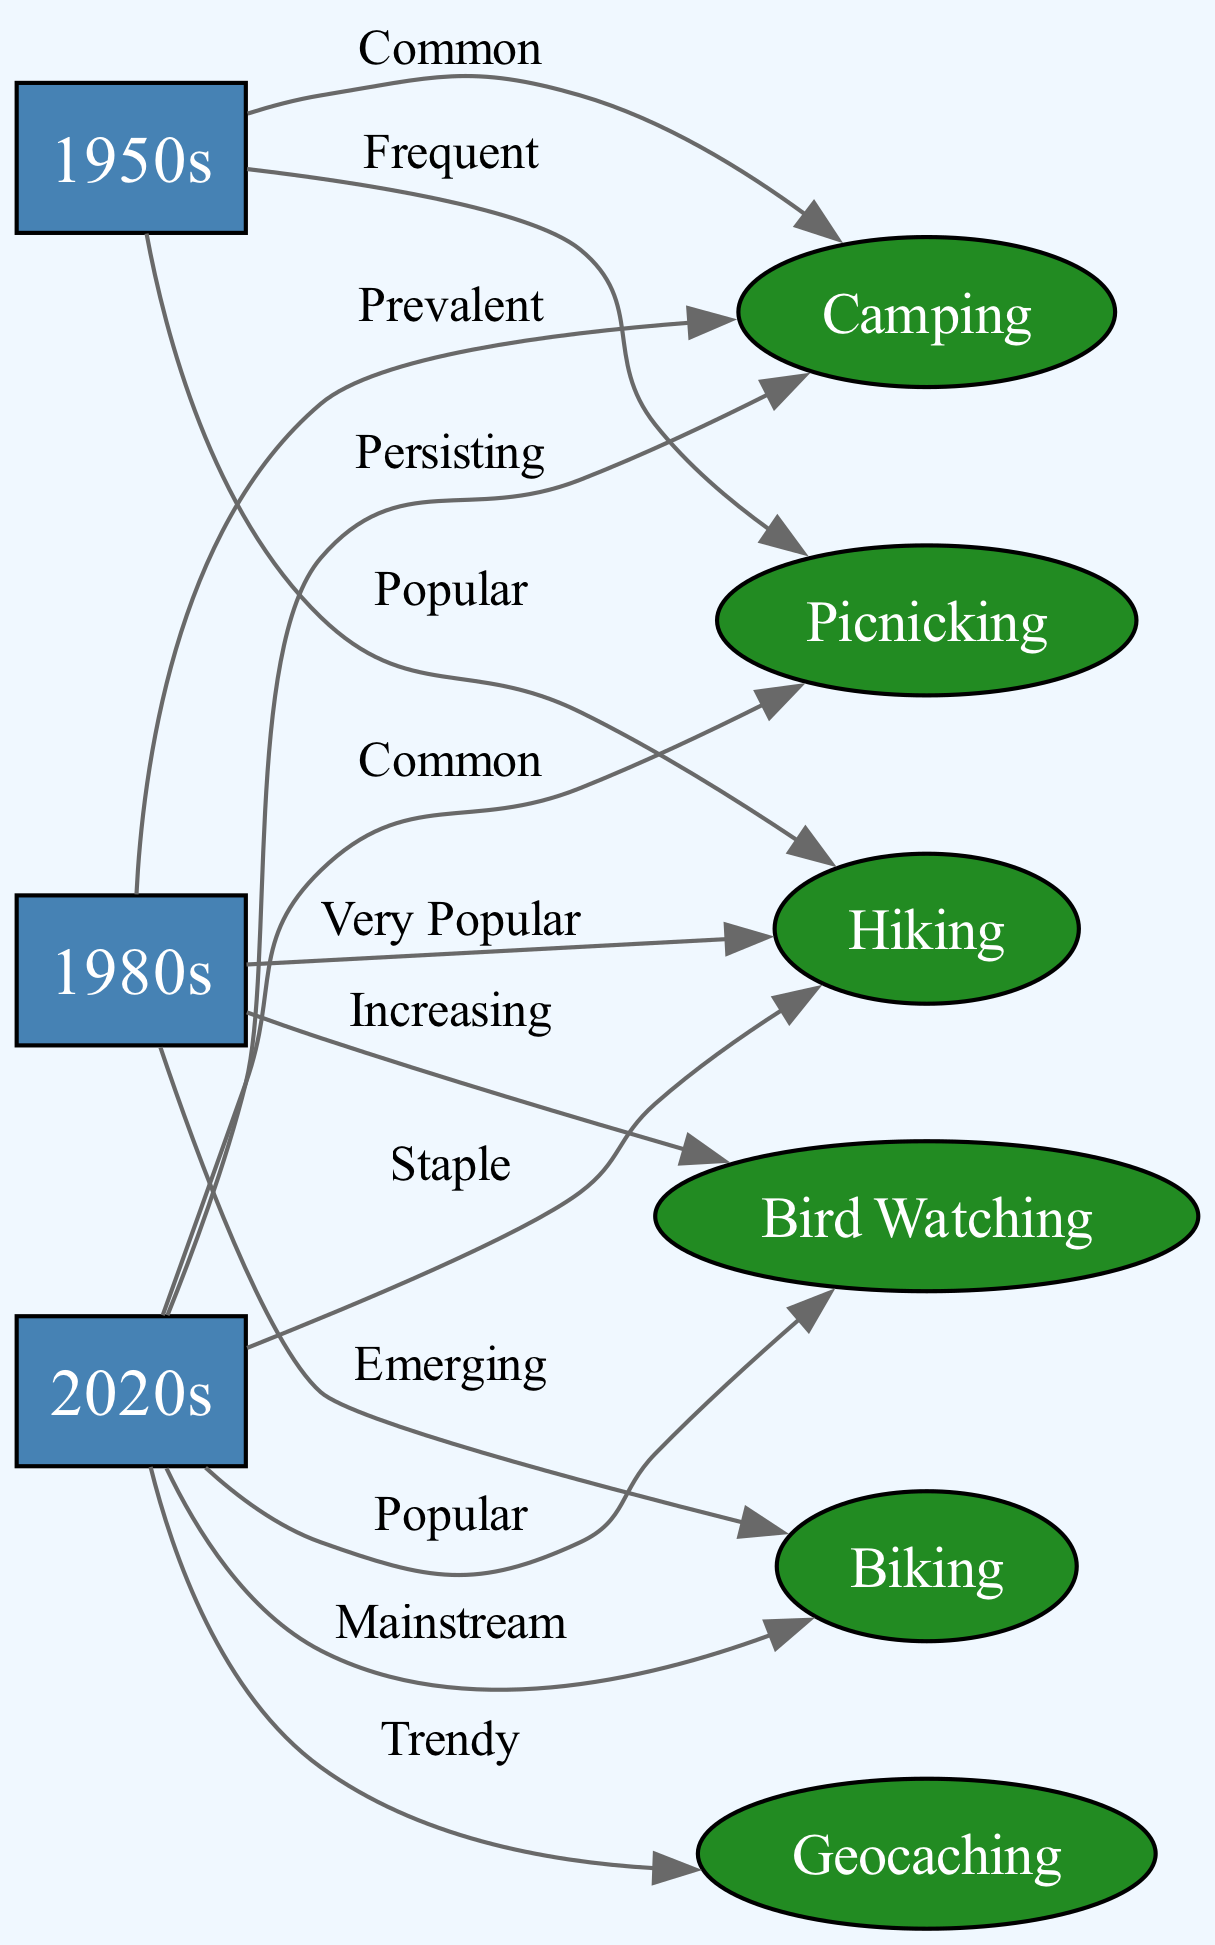What recreational activity was labeled as "Frequent" in the 1950s? In the diagram, I can see that the edge from the node "1950s" to the node "Picnicking" has the label "Frequent." This indicates that picnicking was a common recreational activity during that time.
Answer: Picnicking Which activity is described as "Emerging" in the 1980s? The relationship between the node "1980s" and the node "Biking" is labeled "Emerging." This label implies that biking was gaining popularity during the 1980s.
Answer: Biking What is the total number of recreational activities mentioned in the diagram? To find the total number of recreational activities, I can count the activity nodes present. There are six activity nodes: Hiking, Bird Watching, Camping, Biking, Geocaching, and Picnicking. The total is six.
Answer: 6 What was the status of Bird Watching in the 2020s? The edge from the node "2020s" to the node "Bird Watching" shows the label "Popular." This indicates that bird watching was widely practiced in the 2020s.
Answer: Popular Which activity transitioned from "Emerging" in the 1980s to "Mainstream" in the 2020s? By examining the connections, I see that "Biking" is labeled as "Emerging" from "1980s" and "Mainstream" from "2020s." Thus, biking's status evolved over time to become widely accepted.
Answer: Biking During which decade was Camping described as "Common"? In the diagram, the edge from "1950s" to "Camping" is labeled "Common." This means that camping was regarded as a common activity during the 1950s.
Answer: 1950s Which recreational activity is indicated as "Trendy" in the 2020s? The edge connecting the node "2020s" to the node "Geocaching" has the label "Trendy." This suggests that geocaching was becoming a popular trend during that time.
Answer: Geocaching What is the label associated with Hiking in the 2020s? The connection from "2020s" to "Hiking" is marked as "Staple." This means hiking was a fundamental recreational activity in the 2020s.
Answer: Staple What was the status of Camping in the 1980s? The diagram shows that the edge from "1980s" to "Camping" is labeled "Prevalent." This indicates that camping was a commonly practiced activity in that decade.
Answer: Prevalent 